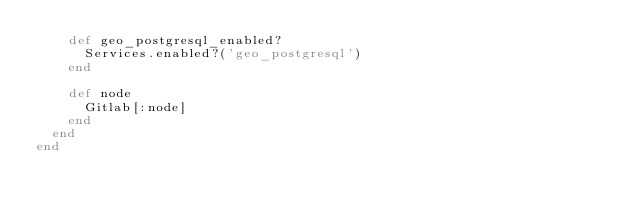Convert code to text. <code><loc_0><loc_0><loc_500><loc_500><_Ruby_>    def geo_postgresql_enabled?
      Services.enabled?('geo_postgresql')
    end

    def node
      Gitlab[:node]
    end
  end
end
</code> 